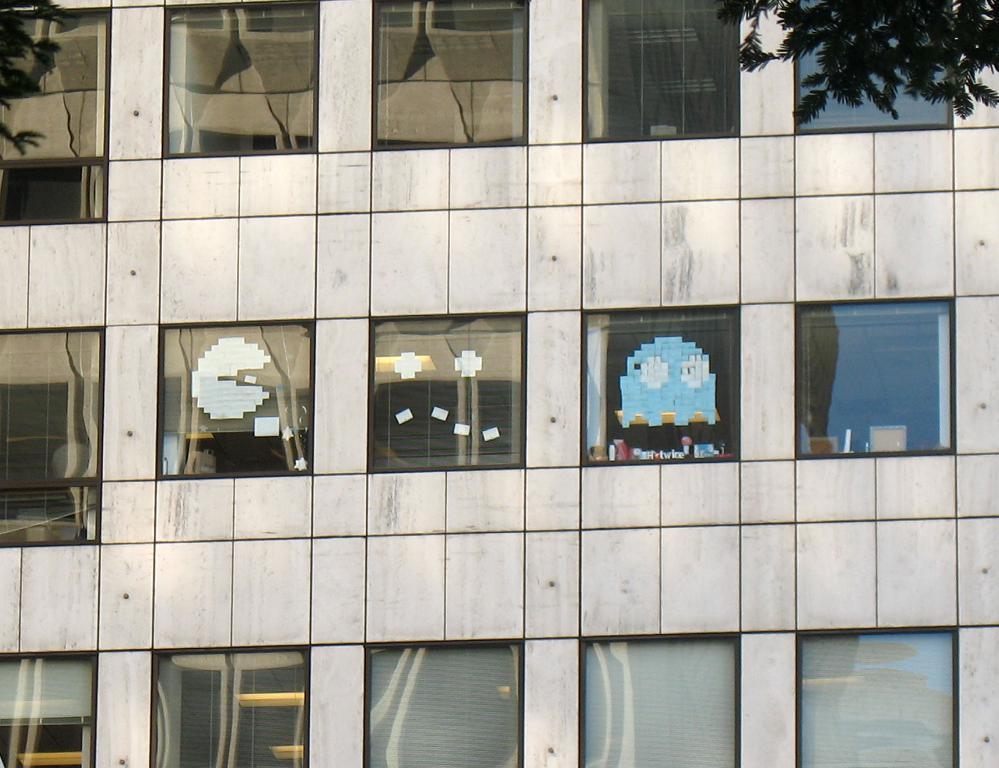Could you give a brief overview of what you see in this image? In this picture I can see there is a building and it has few windows and there are few stickers pasted on the windows. There is a tree at right side. 